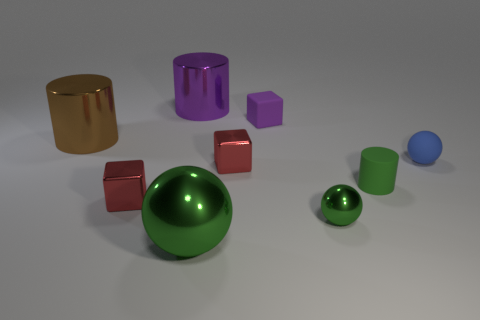What is the size of the red cube to the right of the metal cylinder behind the tiny purple thing?
Your answer should be compact. Small. Does the red block that is in front of the green matte cylinder have the same material as the red block behind the green rubber cylinder?
Offer a terse response. Yes. There is a metal cube that is on the left side of the big sphere; is it the same color as the big metal sphere?
Provide a short and direct response. No. There is a small purple cube; what number of small cubes are right of it?
Ensure brevity in your answer.  0. Does the purple cylinder have the same material as the tiny ball that is to the left of the blue matte sphere?
Provide a short and direct response. Yes. What is the size of the brown cylinder that is made of the same material as the large green thing?
Give a very brief answer. Large. Is the number of small red objects that are left of the purple metallic object greater than the number of big green objects that are on the right side of the tiny purple matte thing?
Your answer should be compact. Yes. Are there any rubber things that have the same shape as the big green metal object?
Your response must be concise. Yes. There is a metallic cube in front of the green matte thing; is its size the same as the matte cube?
Offer a terse response. Yes. Is there a small blue ball?
Your answer should be very brief. Yes. 